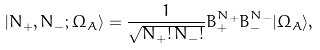<formula> <loc_0><loc_0><loc_500><loc_500>| N _ { + } , N _ { - } ; \Omega _ { A } \rangle = \frac { 1 } { \sqrt { N _ { + } ! \, N _ { - } ! } } B ^ { N _ { + } } _ { + } B ^ { N _ { - } } _ { - } | \Omega _ { A } \rangle ,</formula> 